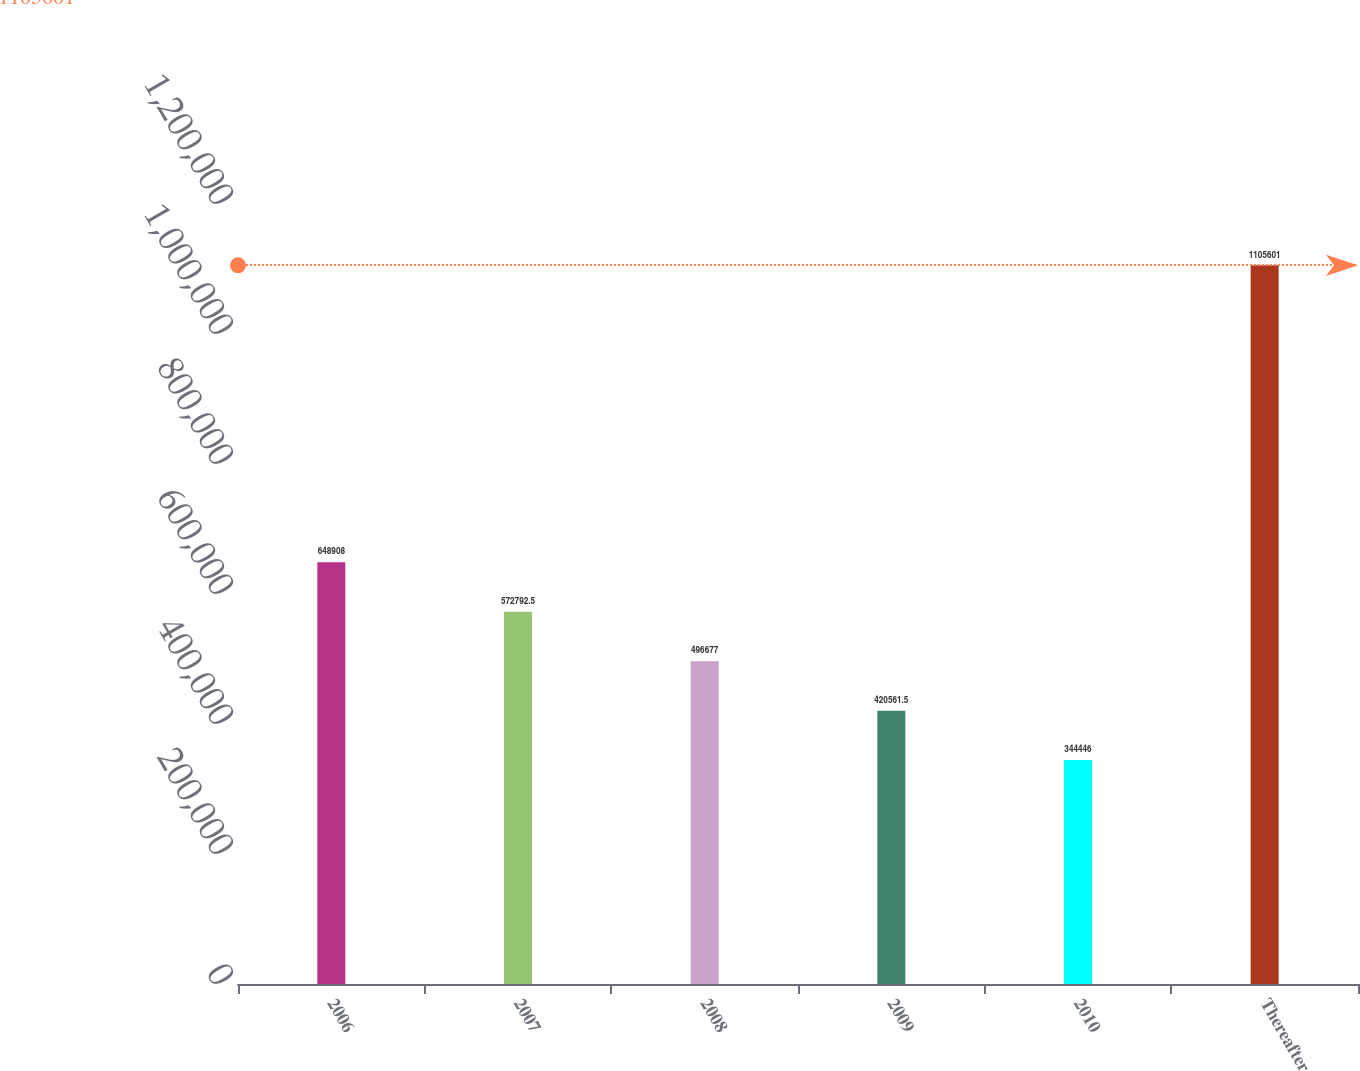Convert chart to OTSL. <chart><loc_0><loc_0><loc_500><loc_500><bar_chart><fcel>2006<fcel>2007<fcel>2008<fcel>2009<fcel>2010<fcel>Thereafter<nl><fcel>648908<fcel>572792<fcel>496677<fcel>420562<fcel>344446<fcel>1.1056e+06<nl></chart> 